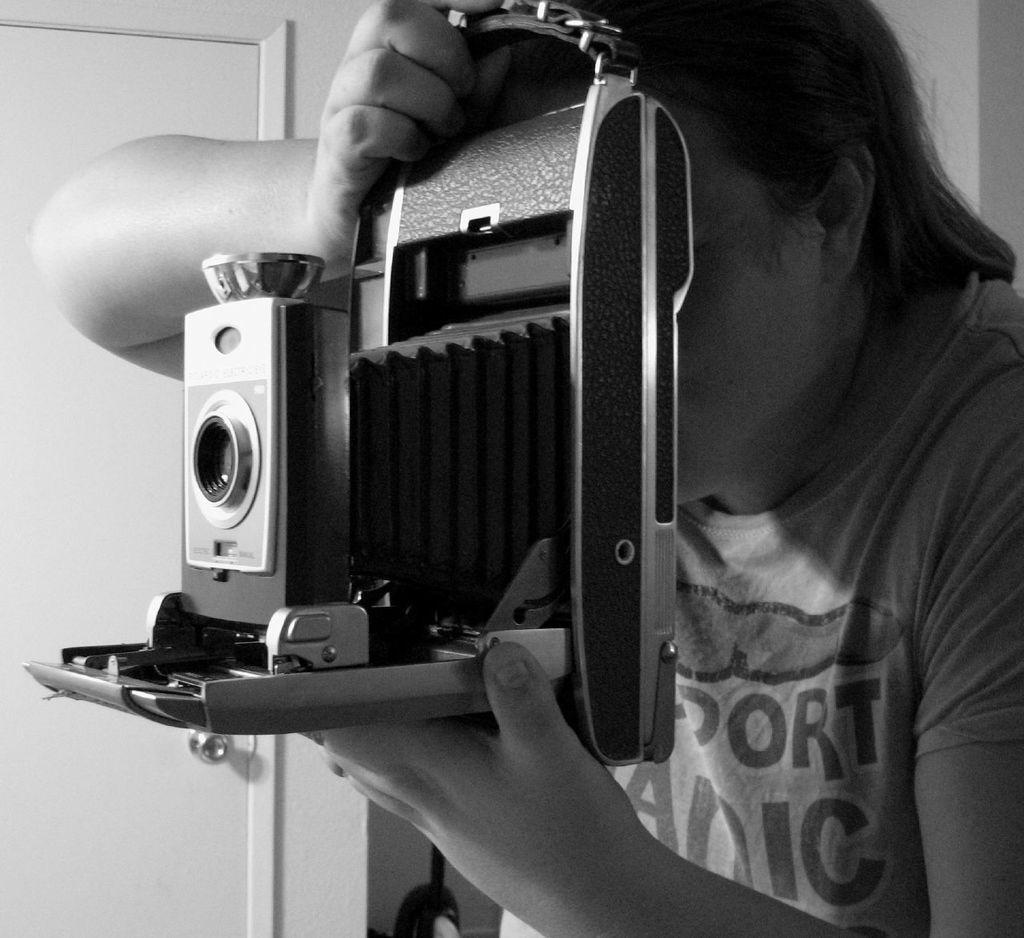Who or what is the main subject of the image? There is a person in the image. What is the person holding in their hand? The person is holding a camera in their hand. What can be seen in the background of the image? There is a door and a wall in the background of the image. Where was the image taken? The image was taken in a room. What type of jam is being spread on the sink in the image? There is no jam or sink present in the image; it features a person holding a camera in a room with a door and a wall in the background. 